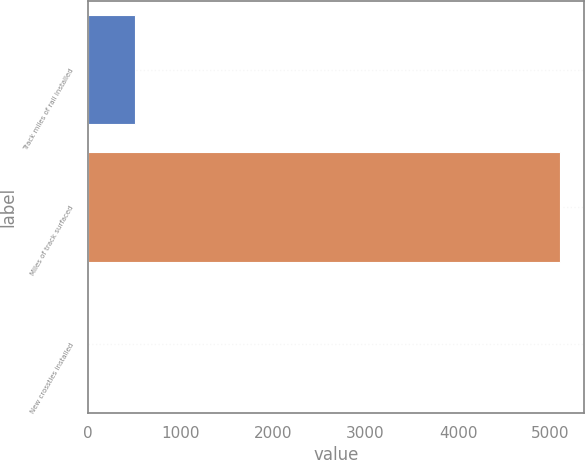<chart> <loc_0><loc_0><loc_500><loc_500><bar_chart><fcel>Track miles of rail installed<fcel>Miles of track surfaced<fcel>New crossties installed<nl><fcel>513.02<fcel>5105<fcel>2.8<nl></chart> 